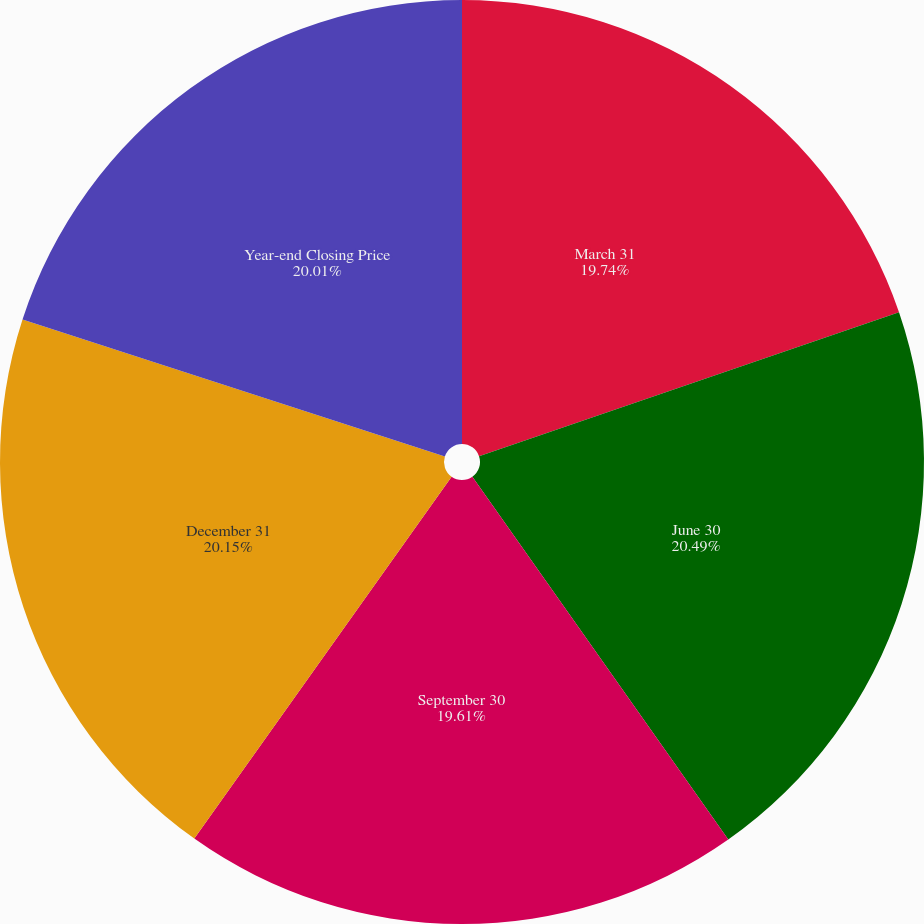Convert chart to OTSL. <chart><loc_0><loc_0><loc_500><loc_500><pie_chart><fcel>March 31<fcel>June 30<fcel>September 30<fcel>December 31<fcel>Year-end Closing Price<nl><fcel>19.74%<fcel>20.48%<fcel>19.61%<fcel>20.15%<fcel>20.01%<nl></chart> 